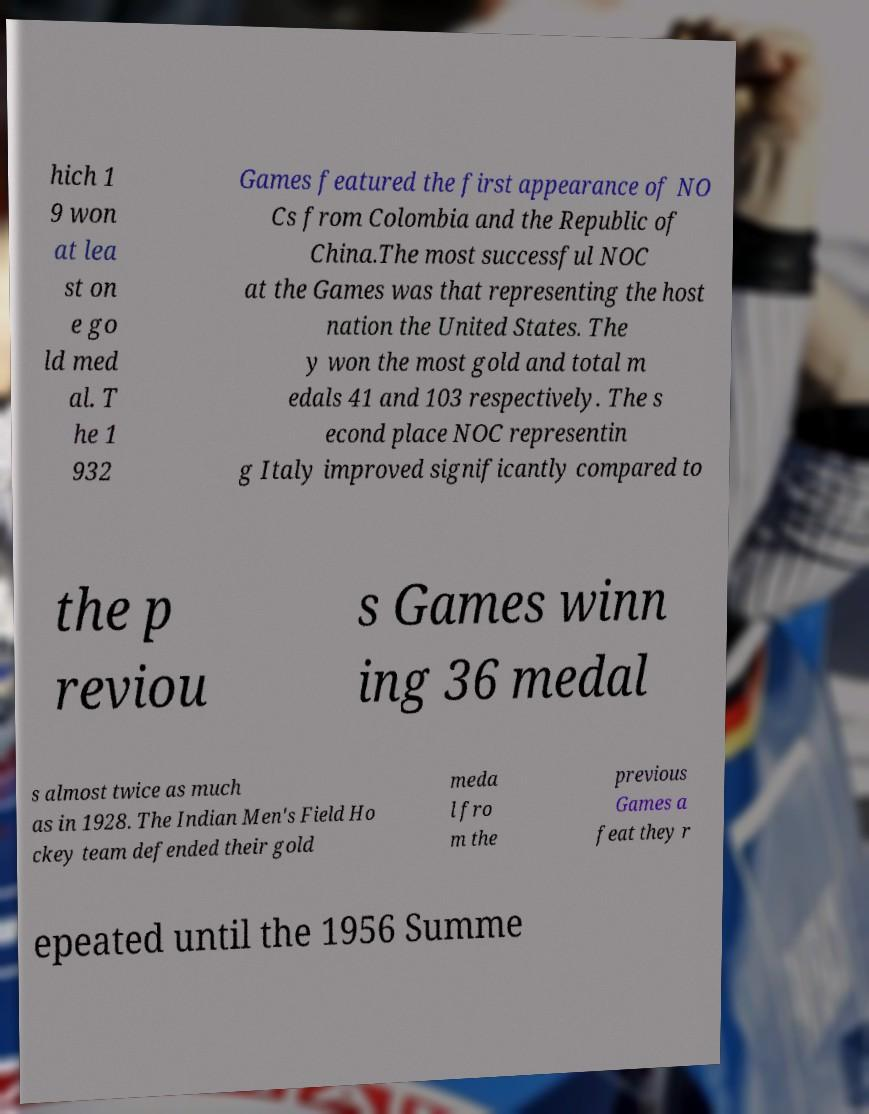Could you extract and type out the text from this image? hich 1 9 won at lea st on e go ld med al. T he 1 932 Games featured the first appearance of NO Cs from Colombia and the Republic of China.The most successful NOC at the Games was that representing the host nation the United States. The y won the most gold and total m edals 41 and 103 respectively. The s econd place NOC representin g Italy improved significantly compared to the p reviou s Games winn ing 36 medal s almost twice as much as in 1928. The Indian Men's Field Ho ckey team defended their gold meda l fro m the previous Games a feat they r epeated until the 1956 Summe 